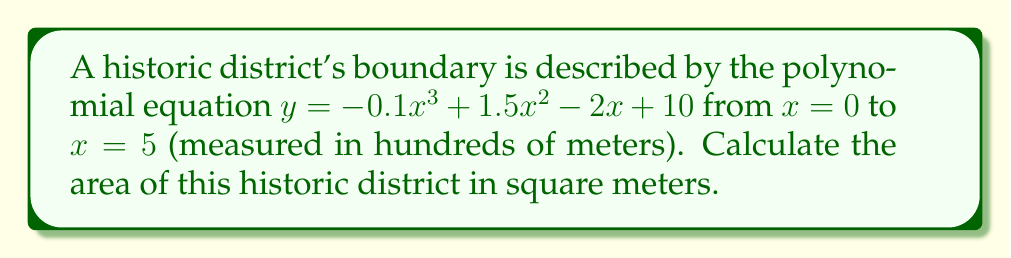Could you help me with this problem? To calculate the area of the historic district, we need to find the definite integral of the polynomial function from $x = 0$ to $x = 5$. This will give us the area under the curve in the given interval.

1) The polynomial function is:
   $f(x) = -0.1x^3 + 1.5x^2 - 2x + 10$

2) To find the area, we integrate this function from 0 to 5:
   $$A = \int_0^5 (-0.1x^3 + 1.5x^2 - 2x + 10) dx$$

3) Integrate each term:
   $$A = [-0.025x^4 + 0.5x^3 - x^2 + 10x]_0^5$$

4) Evaluate the integral at the upper and lower bounds:
   $$A = (-0.025(5^4) + 0.5(5^3) - (5^2) + 10(5)) - (-0.025(0^4) + 0.5(0^3) - (0^2) + 10(0))$$

5) Simplify:
   $$A = (-15.625 + 62.5 - 25 + 50) - (0)$$
   $$A = 71.875$$

6) Since x was measured in hundreds of meters, we need to multiply our result by 10,000 to convert to square meters:
   $$A = 71.875 * 10,000 = 718,750 \text{ square meters}$$
Answer: The area of the historic district is 718,750 square meters. 